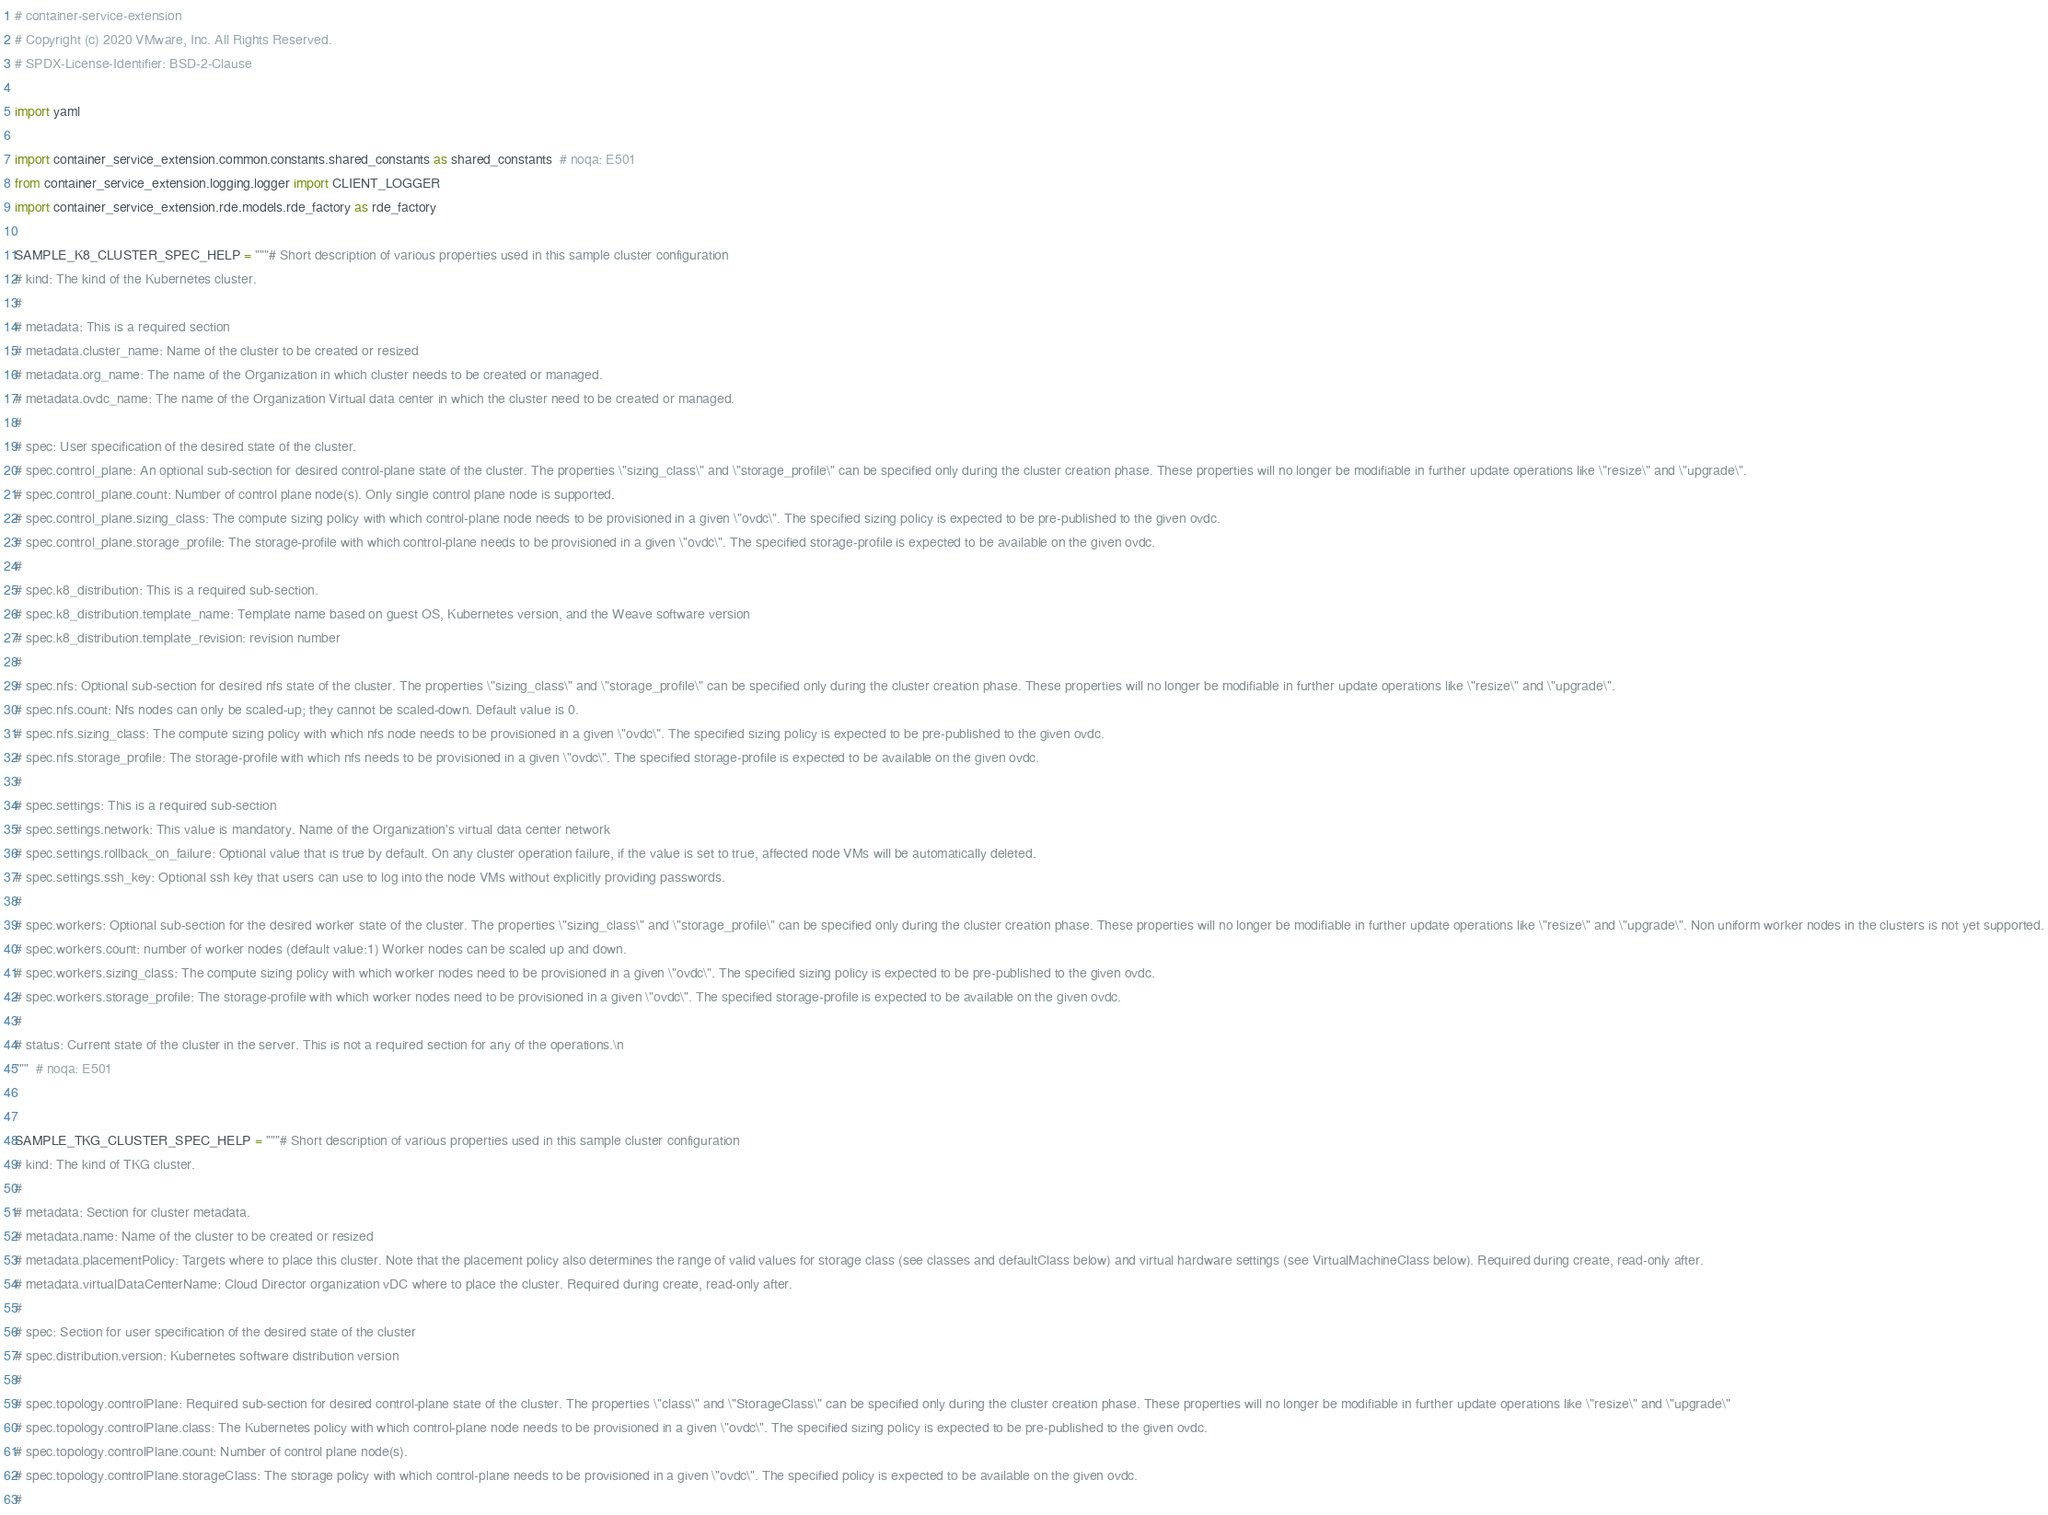Convert code to text. <code><loc_0><loc_0><loc_500><loc_500><_Python_># container-service-extension
# Copyright (c) 2020 VMware, Inc. All Rights Reserved.
# SPDX-License-Identifier: BSD-2-Clause

import yaml

import container_service_extension.common.constants.shared_constants as shared_constants  # noqa: E501
from container_service_extension.logging.logger import CLIENT_LOGGER
import container_service_extension.rde.models.rde_factory as rde_factory

SAMPLE_K8_CLUSTER_SPEC_HELP = """# Short description of various properties used in this sample cluster configuration
# kind: The kind of the Kubernetes cluster.
#
# metadata: This is a required section
# metadata.cluster_name: Name of the cluster to be created or resized
# metadata.org_name: The name of the Organization in which cluster needs to be created or managed.
# metadata.ovdc_name: The name of the Organization Virtual data center in which the cluster need to be created or managed.
#
# spec: User specification of the desired state of the cluster.
# spec.control_plane: An optional sub-section for desired control-plane state of the cluster. The properties \"sizing_class\" and \"storage_profile\" can be specified only during the cluster creation phase. These properties will no longer be modifiable in further update operations like \"resize\" and \"upgrade\".
# spec.control_plane.count: Number of control plane node(s). Only single control plane node is supported.
# spec.control_plane.sizing_class: The compute sizing policy with which control-plane node needs to be provisioned in a given \"ovdc\". The specified sizing policy is expected to be pre-published to the given ovdc.
# spec.control_plane.storage_profile: The storage-profile with which control-plane needs to be provisioned in a given \"ovdc\". The specified storage-profile is expected to be available on the given ovdc.
#
# spec.k8_distribution: This is a required sub-section.
# spec.k8_distribution.template_name: Template name based on guest OS, Kubernetes version, and the Weave software version
# spec.k8_distribution.template_revision: revision number
#
# spec.nfs: Optional sub-section for desired nfs state of the cluster. The properties \"sizing_class\" and \"storage_profile\" can be specified only during the cluster creation phase. These properties will no longer be modifiable in further update operations like \"resize\" and \"upgrade\".
# spec.nfs.count: Nfs nodes can only be scaled-up; they cannot be scaled-down. Default value is 0.
# spec.nfs.sizing_class: The compute sizing policy with which nfs node needs to be provisioned in a given \"ovdc\". The specified sizing policy is expected to be pre-published to the given ovdc.
# spec.nfs.storage_profile: The storage-profile with which nfs needs to be provisioned in a given \"ovdc\". The specified storage-profile is expected to be available on the given ovdc.
#
# spec.settings: This is a required sub-section
# spec.settings.network: This value is mandatory. Name of the Organization's virtual data center network
# spec.settings.rollback_on_failure: Optional value that is true by default. On any cluster operation failure, if the value is set to true, affected node VMs will be automatically deleted.
# spec.settings.ssh_key: Optional ssh key that users can use to log into the node VMs without explicitly providing passwords.
#
# spec.workers: Optional sub-section for the desired worker state of the cluster. The properties \"sizing_class\" and \"storage_profile\" can be specified only during the cluster creation phase. These properties will no longer be modifiable in further update operations like \"resize\" and \"upgrade\". Non uniform worker nodes in the clusters is not yet supported.
# spec.workers.count: number of worker nodes (default value:1) Worker nodes can be scaled up and down.
# spec.workers.sizing_class: The compute sizing policy with which worker nodes need to be provisioned in a given \"ovdc\". The specified sizing policy is expected to be pre-published to the given ovdc.
# spec.workers.storage_profile: The storage-profile with which worker nodes need to be provisioned in a given \"ovdc\". The specified storage-profile is expected to be available on the given ovdc.
#
# status: Current state of the cluster in the server. This is not a required section for any of the operations.\n
"""  # noqa: E501


SAMPLE_TKG_CLUSTER_SPEC_HELP = """# Short description of various properties used in this sample cluster configuration
# kind: The kind of TKG cluster.
#
# metadata: Section for cluster metadata.
# metadata.name: Name of the cluster to be created or resized
# metadata.placementPolicy: Targets where to place this cluster. Note that the placement policy also determines the range of valid values for storage class (see classes and defaultClass below) and virtual hardware settings (see VirtualMachineClass below). Required during create, read-only after.
# metadata.virtualDataCenterName: Cloud Director organization vDC where to place the cluster. Required during create, read-only after.
#
# spec: Section for user specification of the desired state of the cluster
# spec.distribution.version: Kubernetes software distribution version
#
# spec.topology.controlPlane: Required sub-section for desired control-plane state of the cluster. The properties \"class\" and \"StorageClass\" can be specified only during the cluster creation phase. These properties will no longer be modifiable in further update operations like \"resize\" and \"upgrade\"
# spec.topology.controlPlane.class: The Kubernetes policy with which control-plane node needs to be provisioned in a given \"ovdc\". The specified sizing policy is expected to be pre-published to the given ovdc.
# spec.topology.controlPlane.count: Number of control plane node(s).
# spec.topology.controlPlane.storageClass: The storage policy with which control-plane needs to be provisioned in a given \"ovdc\". The specified policy is expected to be available on the given ovdc.
#</code> 